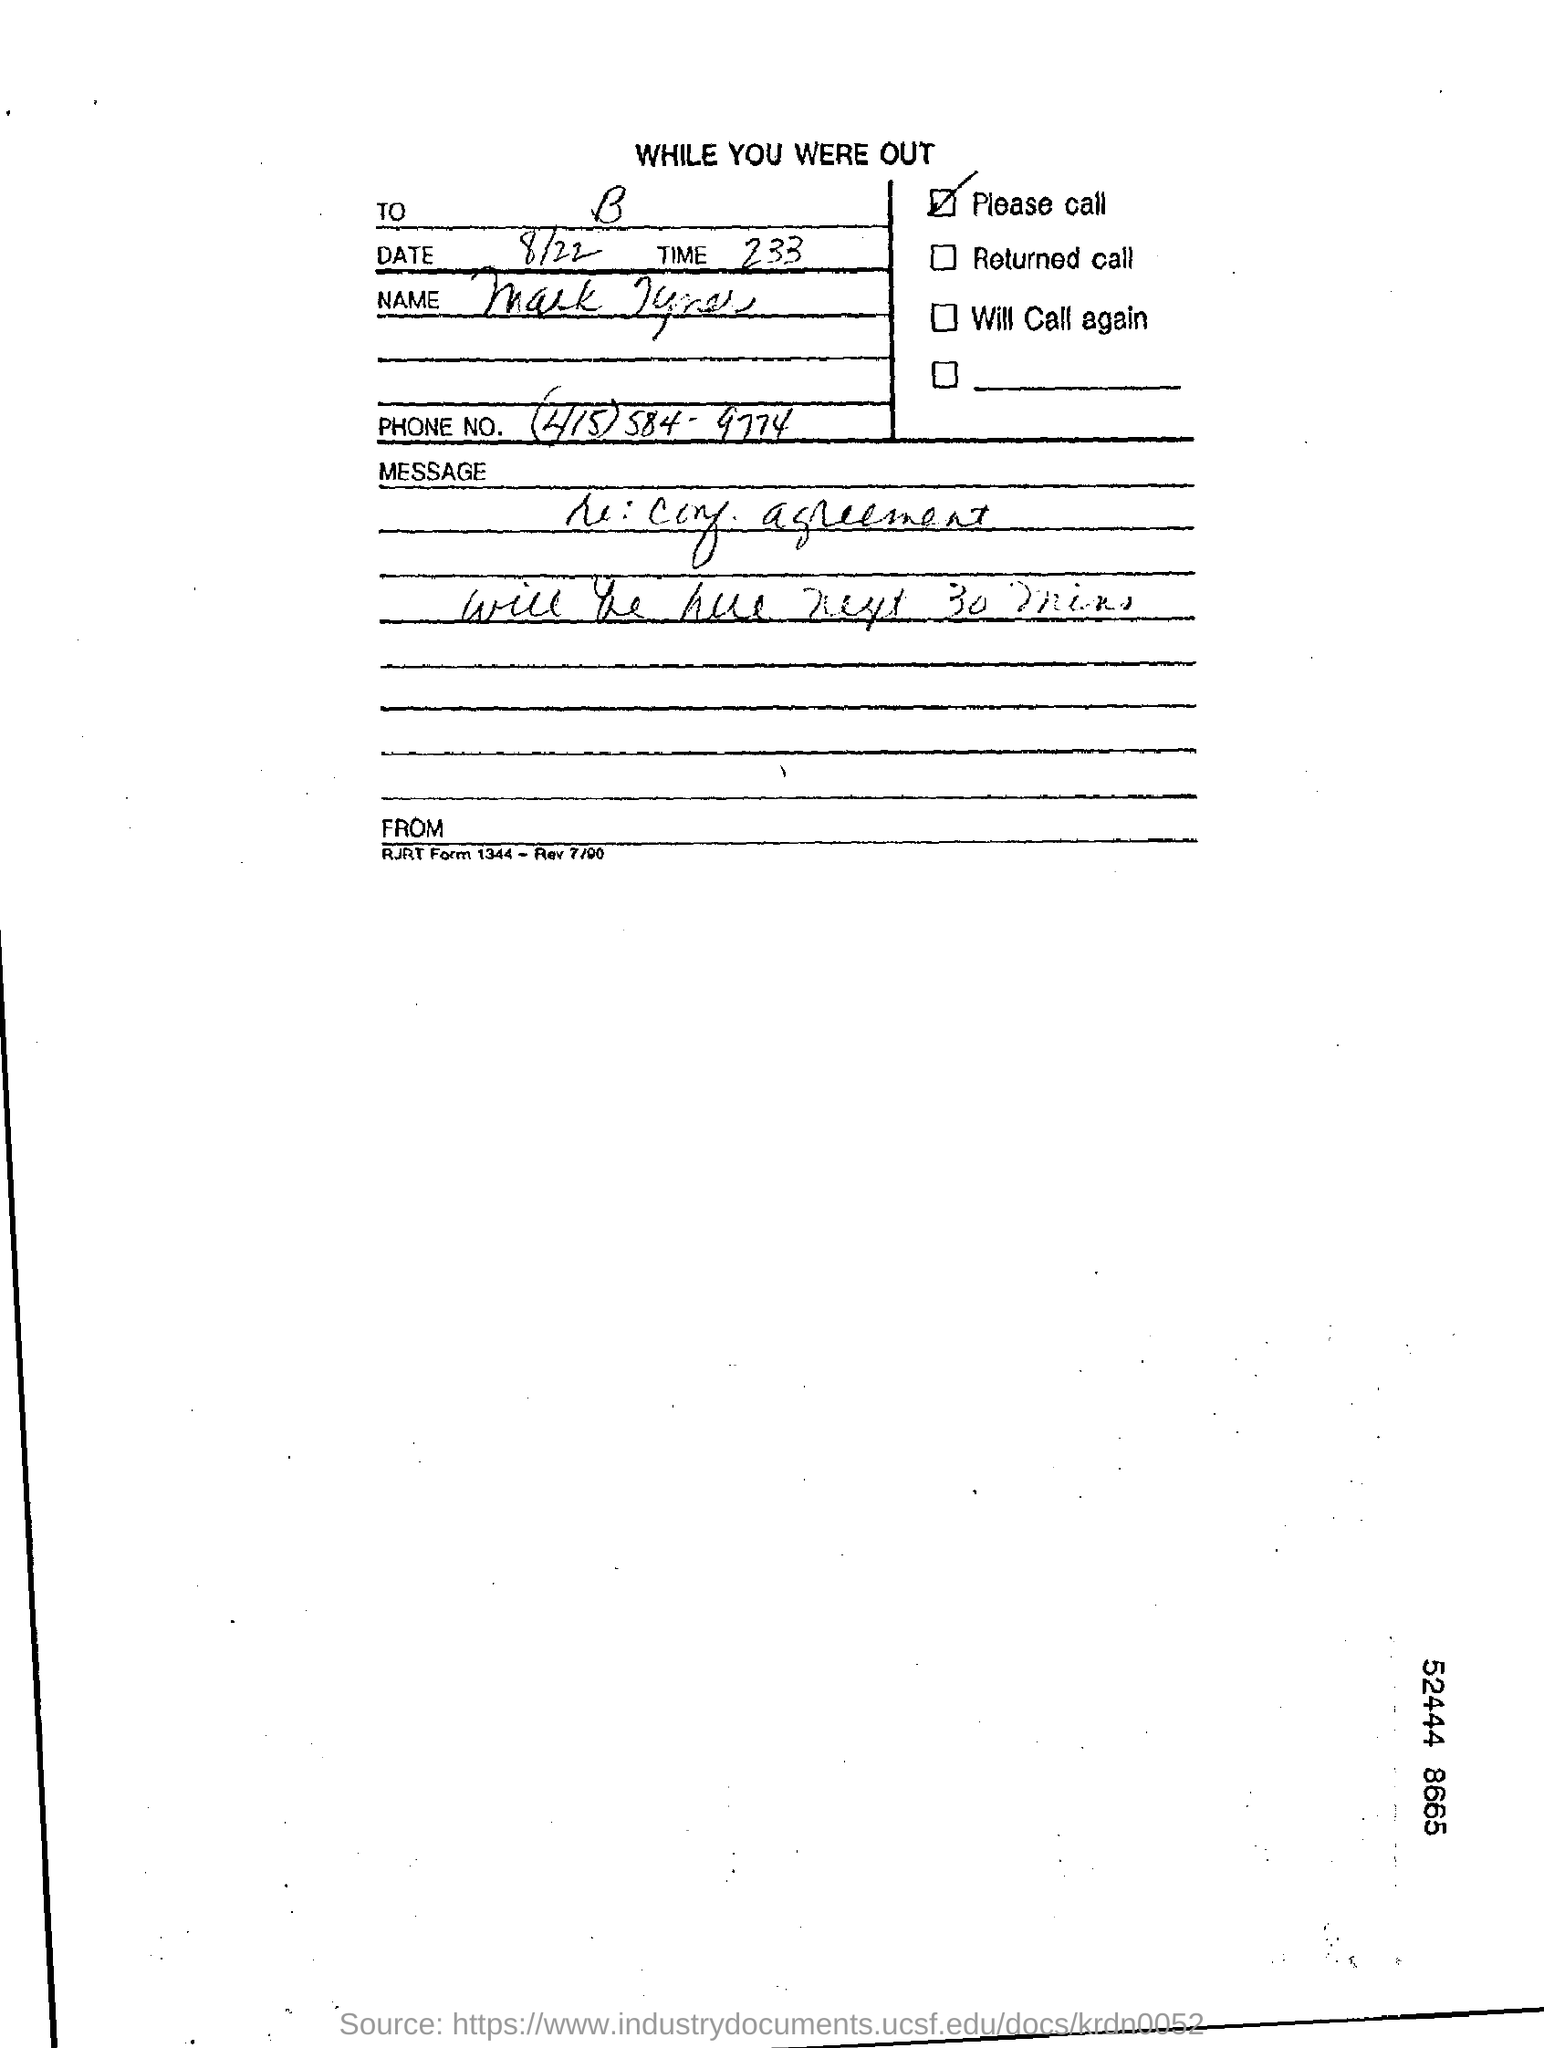Indicate a few pertinent items in this graphic. The date is August 22. 